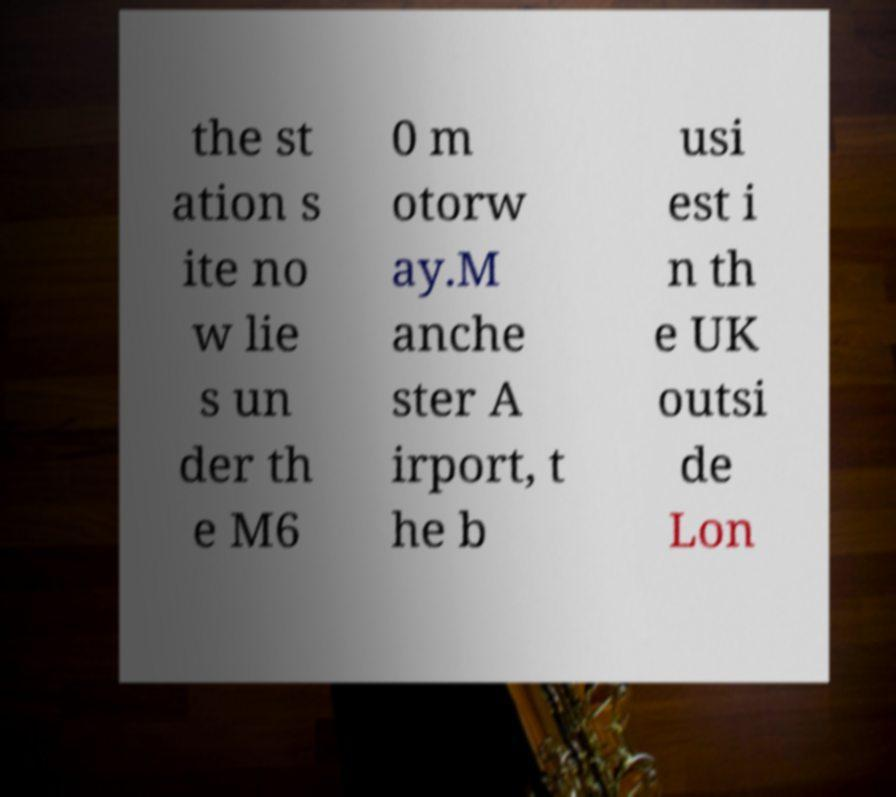Please identify and transcribe the text found in this image. the st ation s ite no w lie s un der th e M6 0 m otorw ay.M anche ster A irport, t he b usi est i n th e UK outsi de Lon 